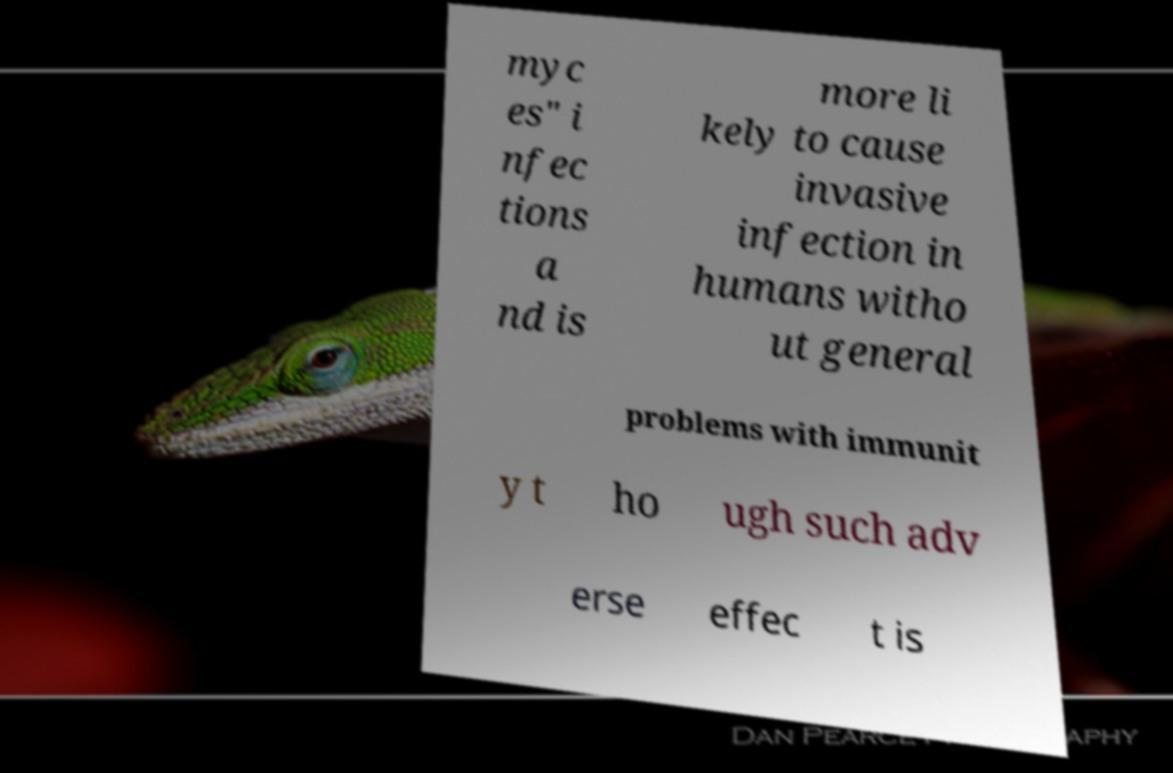Please read and relay the text visible in this image. What does it say? myc es" i nfec tions a nd is more li kely to cause invasive infection in humans witho ut general problems with immunit y t ho ugh such adv erse effec t is 